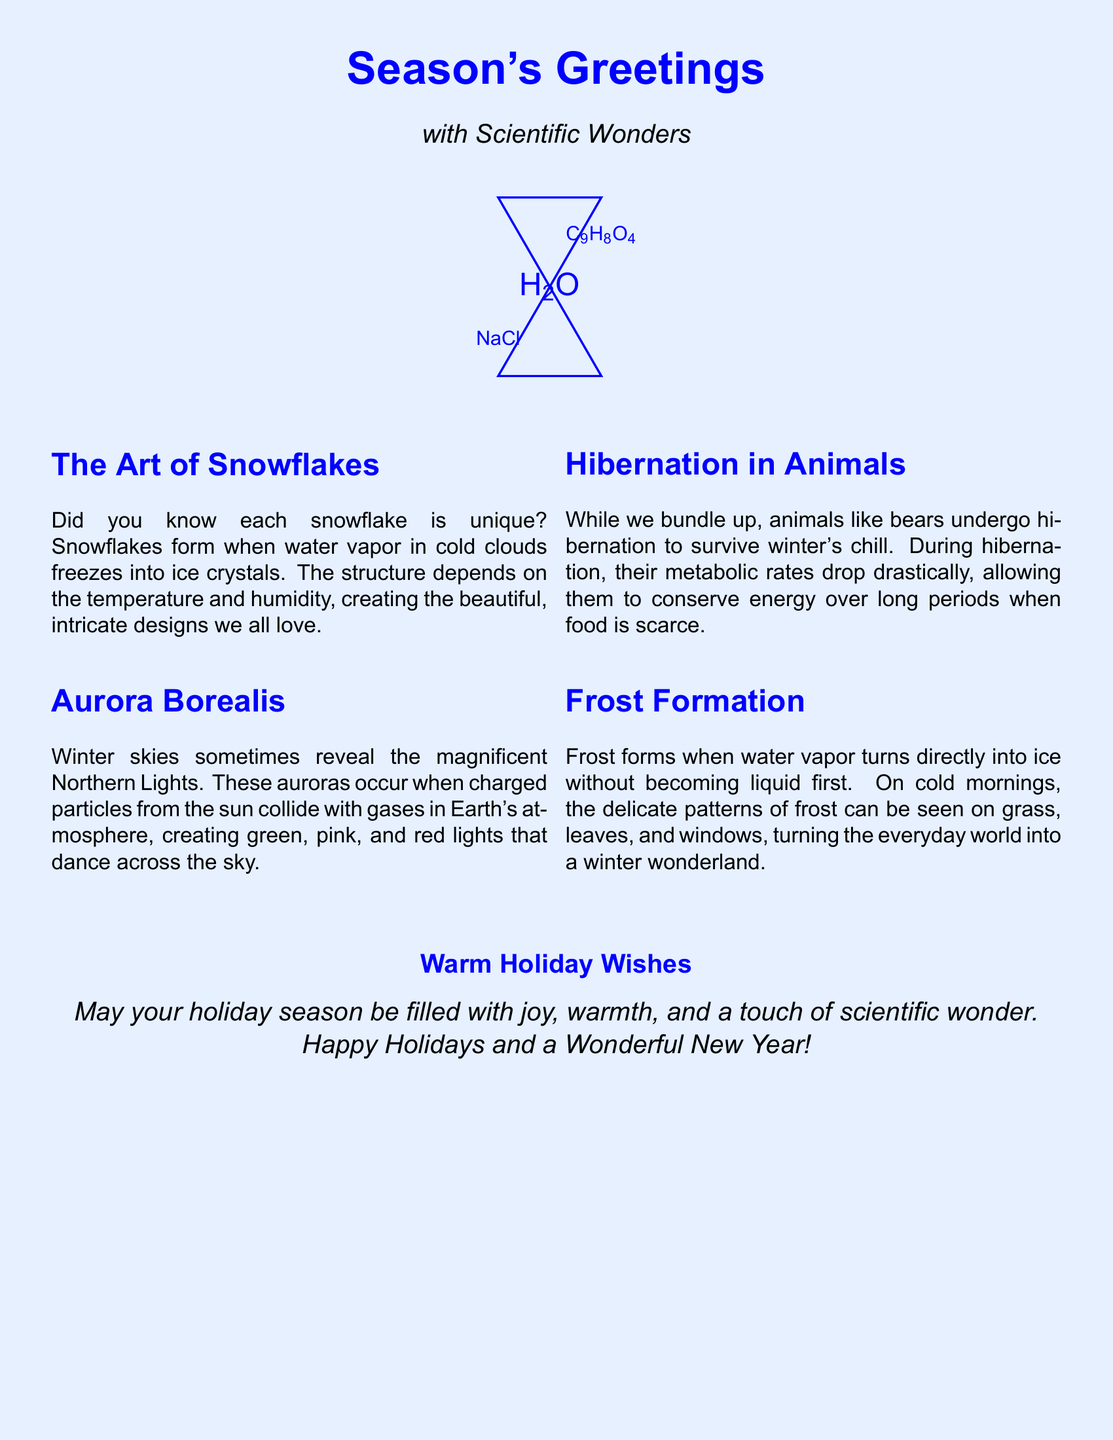What is depicted on the front of the card? The front of the card depicts a snowflake made of chemical formulas.
Answer: A snowflake made of chemical formulas What does H2O represent on the front? H2O is the chemical formula for water, which is relevant for snowflake formation.
Answer: Water What natural phenomenon is mentioned related to winter skies? The document mentions the Aurora Borealis occurring in winter skies.
Answer: Aurora Borealis What do bears do to survive the winter? The document states that bears undergo hibernation during winter.
Answer: Hibernation What is the key message inside the card? The card shares warm holiday wishes filled with joy, warmth, and a touch of scientific wonder.
Answer: Warm Holiday Wishes How are frost patterns formed according to the card? Frost forms when water vapor turns directly into ice without becoming liquid first.
Answer: Water vapor turns into ice What colors are typically seen in the Aurora Borealis? The document mentions green, pink, and red lights produced by the Aurora Borealis.
Answer: Green, pink, and red What holiday sentiment is expressed in the card? The card expresses a sentiment of joy and warmth for the holiday season.
Answer: Joy and warmth What aspect of nature is highlighted in the section about snowflakes? The uniqueness of each snowflake is highlighted in the snowflakes section.
Answer: Uniqueness 